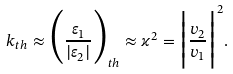Convert formula to latex. <formula><loc_0><loc_0><loc_500><loc_500>k _ { t h } \approx \Big { ( } \frac { \varepsilon _ { 1 } } { | \varepsilon _ { 2 } | } \Big { ) } _ { t h } \approx \varkappa ^ { 2 } = \Big { | } \frac { v _ { 2 } } { v _ { 1 } } \Big { | } ^ { 2 } .</formula> 